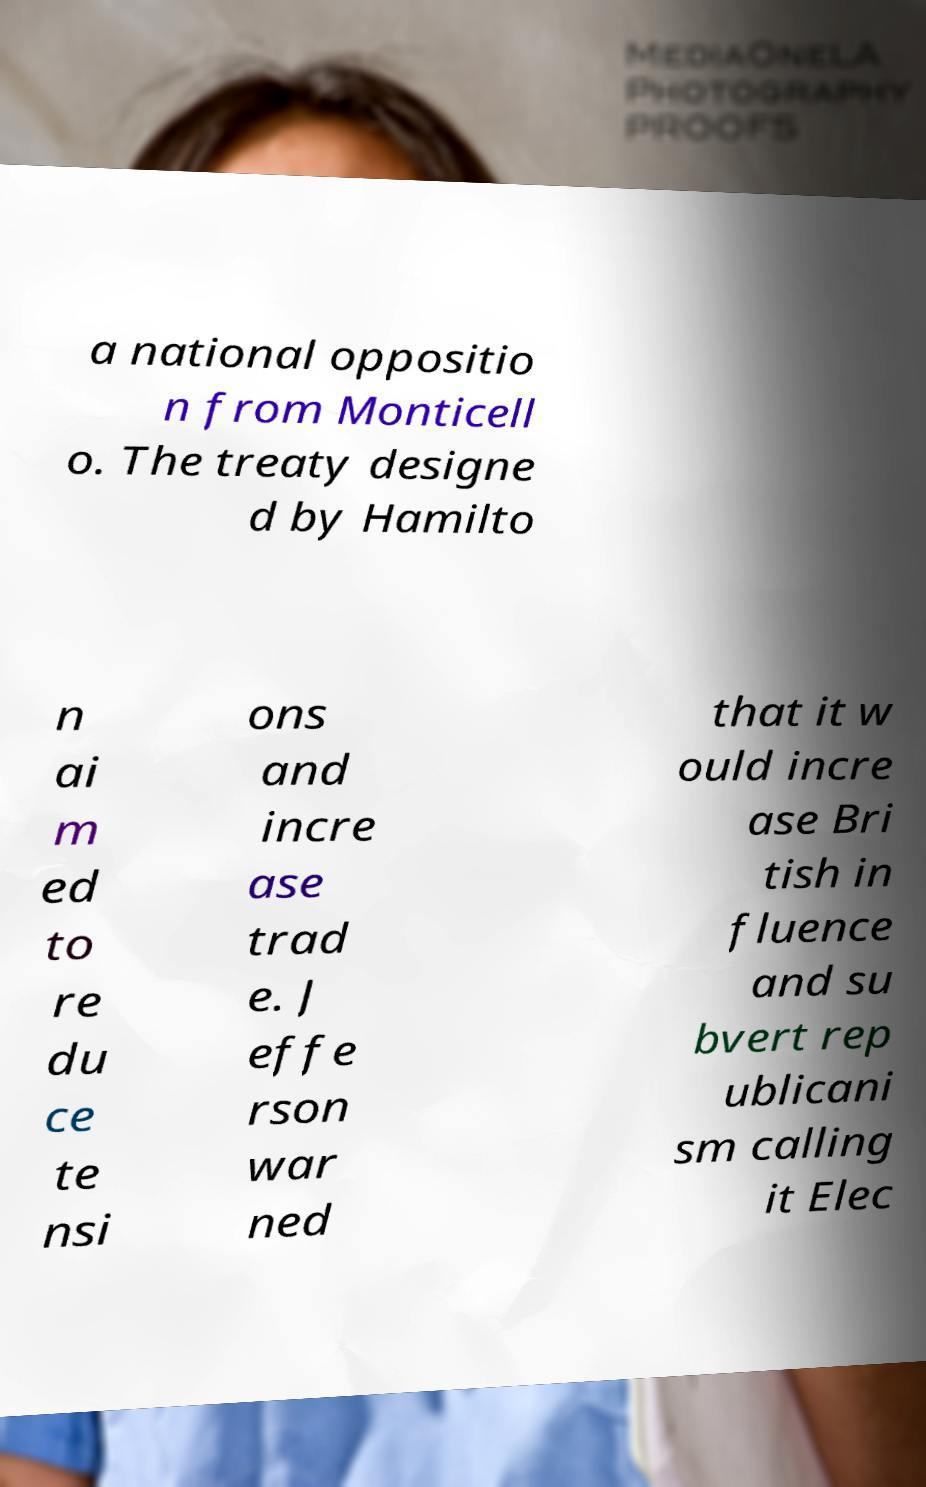Could you extract and type out the text from this image? a national oppositio n from Monticell o. The treaty designe d by Hamilto n ai m ed to re du ce te nsi ons and incre ase trad e. J effe rson war ned that it w ould incre ase Bri tish in fluence and su bvert rep ublicani sm calling it Elec 